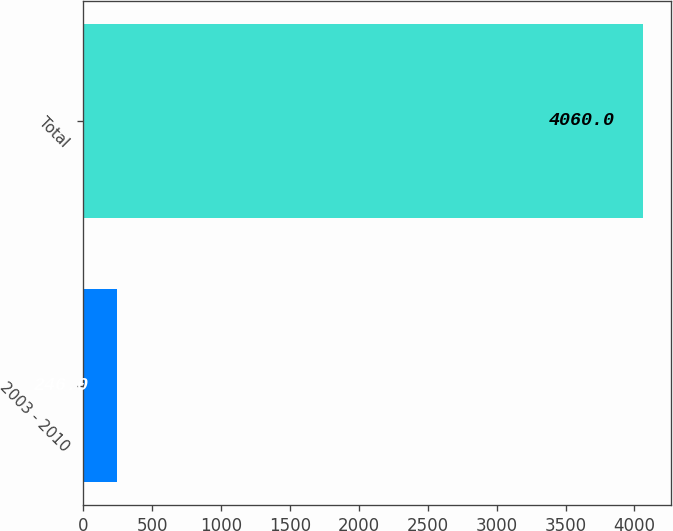Convert chart. <chart><loc_0><loc_0><loc_500><loc_500><bar_chart><fcel>2003 - 2010<fcel>Total<nl><fcel>246<fcel>4060<nl></chart> 